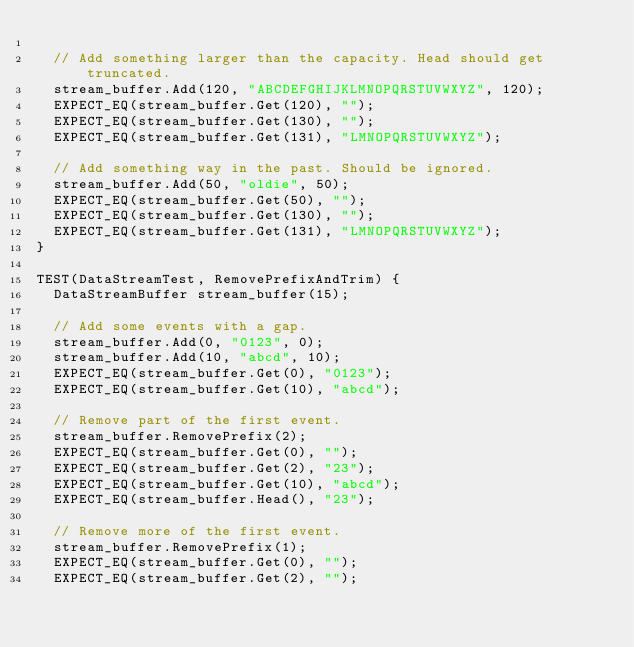Convert code to text. <code><loc_0><loc_0><loc_500><loc_500><_C++_>
  // Add something larger than the capacity. Head should get truncated.
  stream_buffer.Add(120, "ABCDEFGHIJKLMNOPQRSTUVWXYZ", 120);
  EXPECT_EQ(stream_buffer.Get(120), "");
  EXPECT_EQ(stream_buffer.Get(130), "");
  EXPECT_EQ(stream_buffer.Get(131), "LMNOPQRSTUVWXYZ");

  // Add something way in the past. Should be ignored.
  stream_buffer.Add(50, "oldie", 50);
  EXPECT_EQ(stream_buffer.Get(50), "");
  EXPECT_EQ(stream_buffer.Get(130), "");
  EXPECT_EQ(stream_buffer.Get(131), "LMNOPQRSTUVWXYZ");
}

TEST(DataStreamTest, RemovePrefixAndTrim) {
  DataStreamBuffer stream_buffer(15);

  // Add some events with a gap.
  stream_buffer.Add(0, "0123", 0);
  stream_buffer.Add(10, "abcd", 10);
  EXPECT_EQ(stream_buffer.Get(0), "0123");
  EXPECT_EQ(stream_buffer.Get(10), "abcd");

  // Remove part of the first event.
  stream_buffer.RemovePrefix(2);
  EXPECT_EQ(stream_buffer.Get(0), "");
  EXPECT_EQ(stream_buffer.Get(2), "23");
  EXPECT_EQ(stream_buffer.Get(10), "abcd");
  EXPECT_EQ(stream_buffer.Head(), "23");

  // Remove more of the first event.
  stream_buffer.RemovePrefix(1);
  EXPECT_EQ(stream_buffer.Get(0), "");
  EXPECT_EQ(stream_buffer.Get(2), "");</code> 